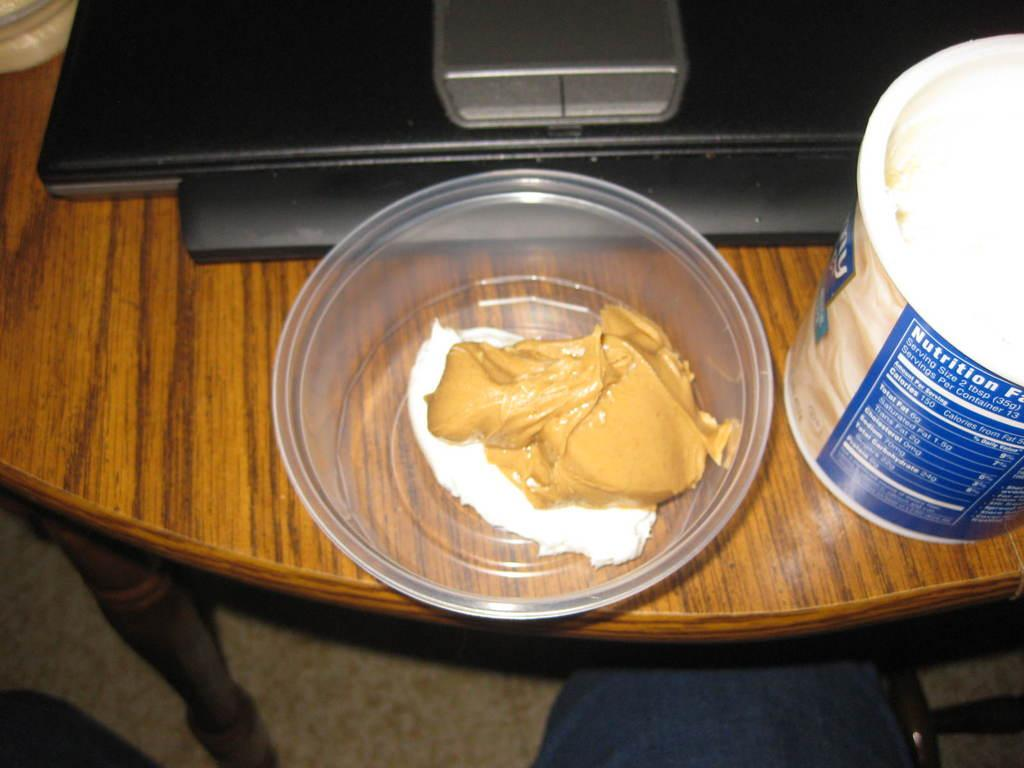What is in the bowl that is visible in the image? There is a bowl with cream in the image. What else can be seen on the table in the image? There is a container and a device on the table in the image. Where are the bowl, container, and device located in the image? They are placed on a table. Can you describe any part of a person visible in the image? The legs of a person are visible at the bottom of the image. What type of coach is present in the image? There is no coach present in the image. What is the iron used for in the image? There is no iron present in the image. 